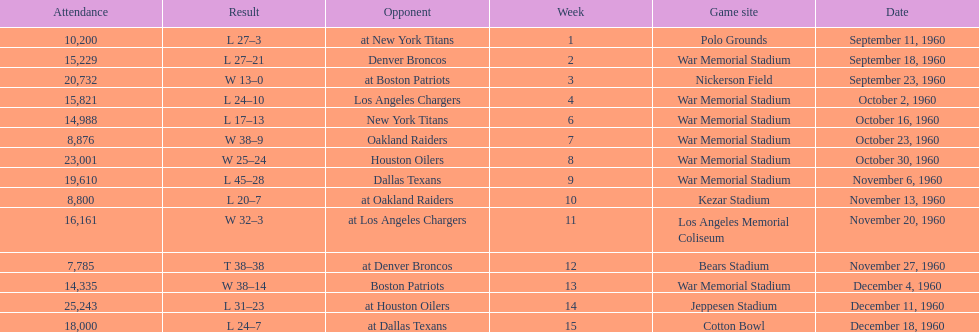How many games were played in total at war memorial stadium? 7. 